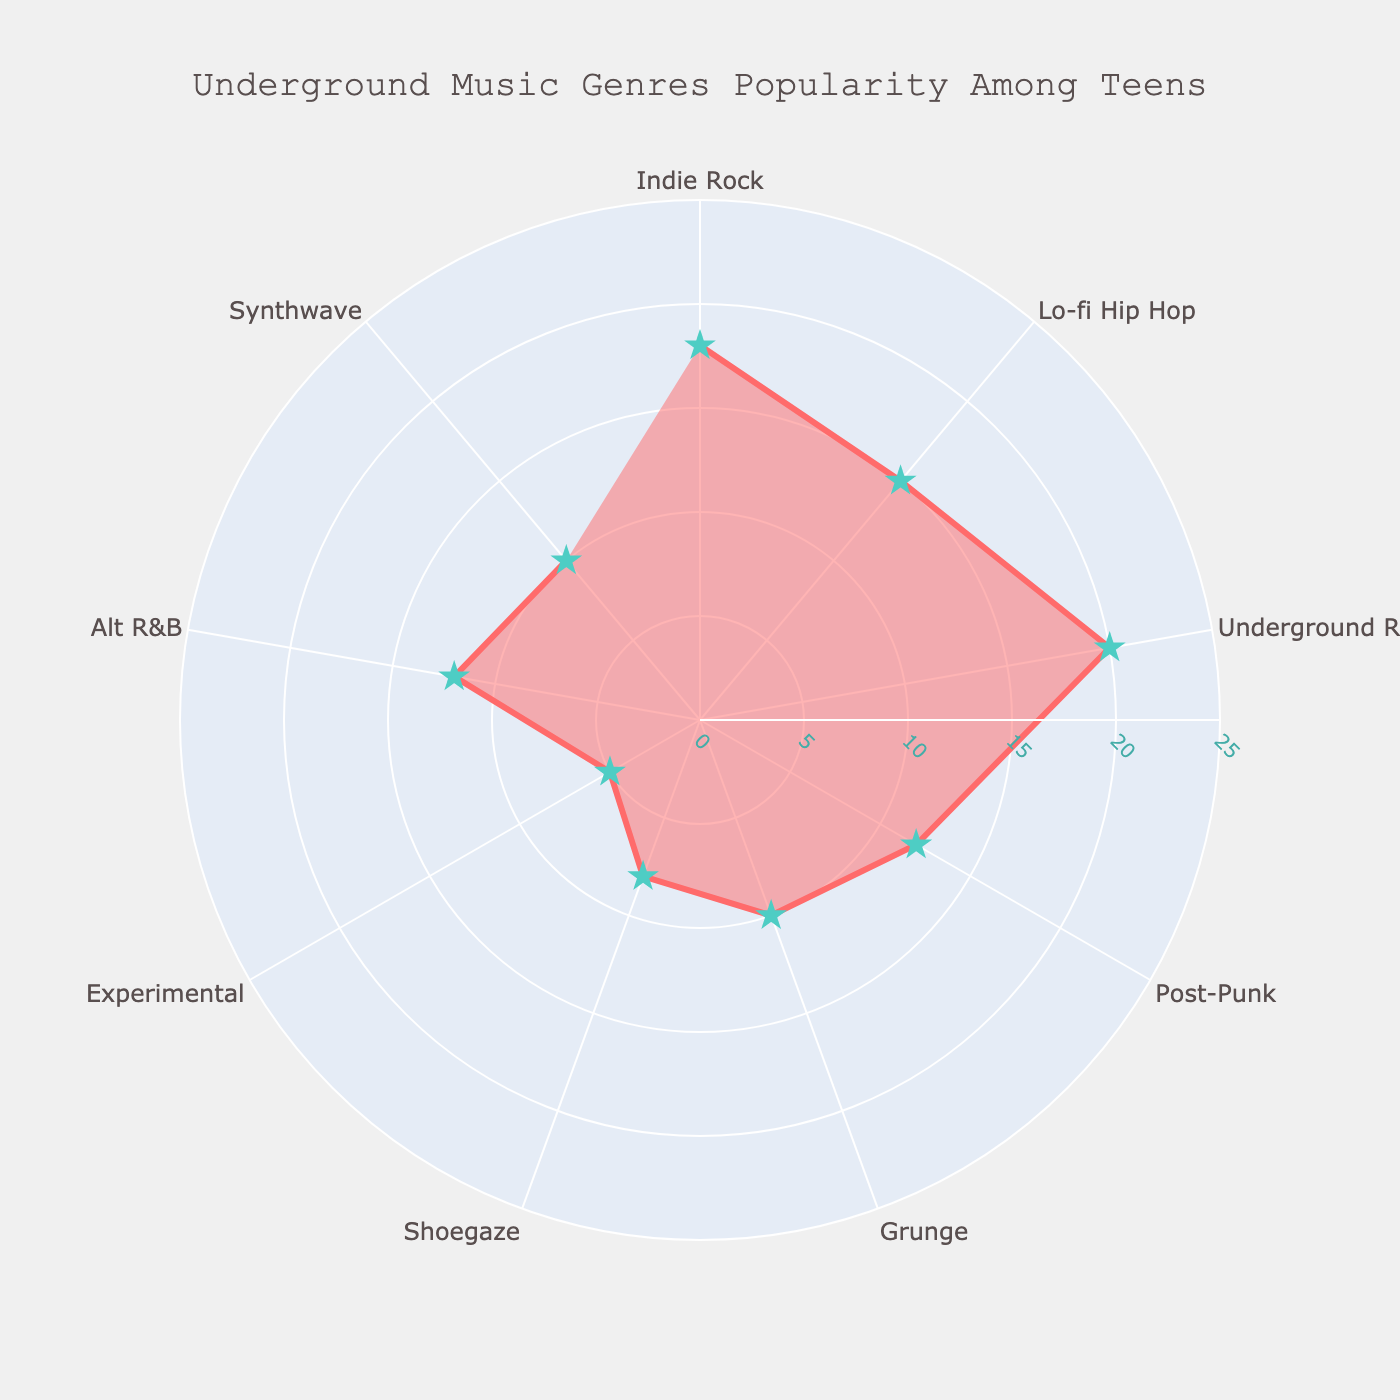what's the title of the figure? The title of the figure is written at the top of the chart. It reads 'Underground Music Genres Popularity Among Teens'
Answer: Underground Music Genres Popularity Among Teens how many genres are shown in the chart? You can count the number of genres listed at the outside of the polar chart. There are 9 genres displayed.
Answer: 9 which genre has the highest popularity percentage? By looking at the respective arcs positions and their radial lengths, the genre with the highest radial value in the figure is Underground Rap. It has a value of 20%.
Answer: Underground Rap what's the combined popularity of Indie Rock and Lo-fi Hip Hop? Add the popularity percentages of Indie Rock and Lo-fi Hip Hop. For Indie Rock, it's 18%, and for Lo-fi Hip Hop, it's 15%. So, 18% + 15% = 33%.
Answer: 33% Which has a greater popularity, Post-Punk or Experimental, and by how much? By comparing the radial values, Post-Punk has a popularity of 12% and Experimental has 5%. The difference is 12% - 5% = 7%.
Answer: Post-Punk by 7% calculate the average popularity of Shoegaze, Synthwave, and Grunge. Sum the popularity percentages of Shoegaze (8%), Synthwave (10%), and Grunge (10%). Total is 8 + 10 + 10 = 28. Divide this by the number of genres (3). The average is 28/3 = 9.33%.
Answer: 9.33% how does Alt R&B's popularity compare to Experimental? Alt R&B has a popularity of 12%, which is greater than 5%, the popularity of Experimental. The difference is 12% - 5% = 7%.
Answer: Greater by 7% which genre is represented by the smallest radial distance? The genre with the smallest radial length is Experimental, at 5%.
Answer: Experimental are there any genres with equal popularity percentages? If so, which ones? By comparing the radial values in the chart, Post-Punk and Alt R&B both have the same popularity percentage, which is 12%. Additionally, Grunge and Synthwave both have 10%.
Answer: Post-Punk & Alt R&B, Grunge & Synthwave 